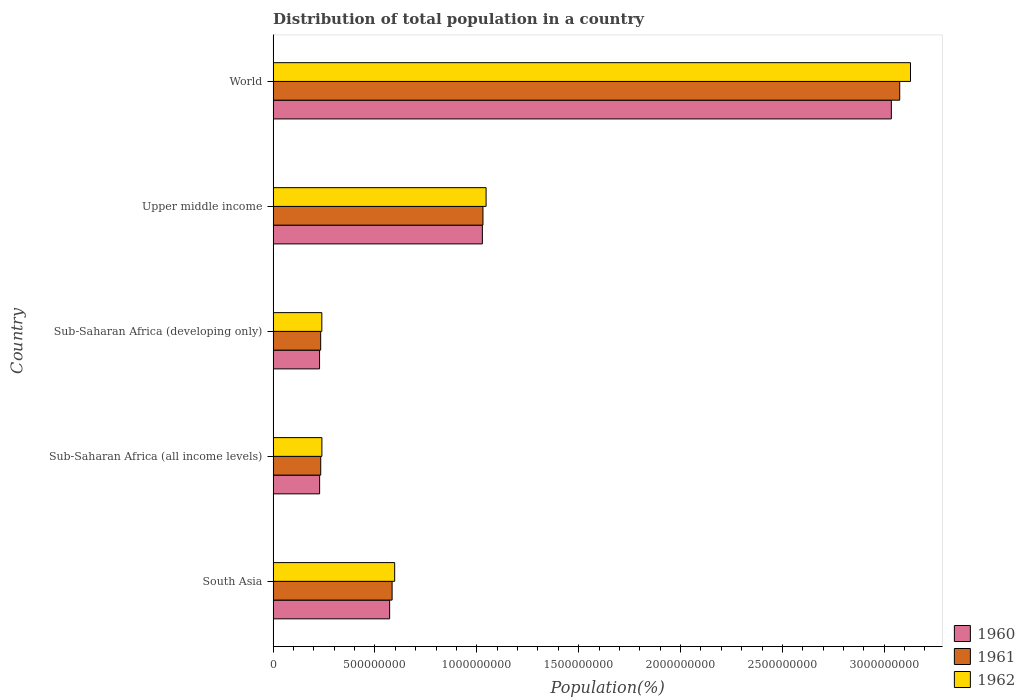Are the number of bars on each tick of the Y-axis equal?
Your answer should be very brief. Yes. How many bars are there on the 1st tick from the bottom?
Your answer should be very brief. 3. What is the label of the 2nd group of bars from the top?
Your answer should be very brief. Upper middle income. What is the population of in 1961 in South Asia?
Provide a short and direct response. 5.84e+08. Across all countries, what is the maximum population of in 1962?
Offer a terse response. 3.13e+09. Across all countries, what is the minimum population of in 1962?
Keep it short and to the point. 2.39e+08. In which country was the population of in 1961 maximum?
Offer a very short reply. World. In which country was the population of in 1960 minimum?
Provide a short and direct response. Sub-Saharan Africa (developing only). What is the total population of in 1960 in the graph?
Your answer should be compact. 5.09e+09. What is the difference between the population of in 1960 in Upper middle income and that in World?
Your answer should be very brief. -2.01e+09. What is the difference between the population of in 1961 in Sub-Saharan Africa (all income levels) and the population of in 1962 in World?
Make the answer very short. -2.90e+09. What is the average population of in 1960 per country?
Keep it short and to the point. 1.02e+09. What is the difference between the population of in 1961 and population of in 1962 in World?
Your answer should be very brief. -5.30e+07. What is the ratio of the population of in 1960 in South Asia to that in Upper middle income?
Give a very brief answer. 0.56. Is the population of in 1961 in Sub-Saharan Africa (all income levels) less than that in Upper middle income?
Ensure brevity in your answer.  Yes. Is the difference between the population of in 1961 in Sub-Saharan Africa (all income levels) and Sub-Saharan Africa (developing only) greater than the difference between the population of in 1962 in Sub-Saharan Africa (all income levels) and Sub-Saharan Africa (developing only)?
Ensure brevity in your answer.  No. What is the difference between the highest and the second highest population of in 1960?
Your answer should be compact. 2.01e+09. What is the difference between the highest and the lowest population of in 1962?
Your response must be concise. 2.89e+09. Is it the case that in every country, the sum of the population of in 1962 and population of in 1961 is greater than the population of in 1960?
Keep it short and to the point. Yes. Are all the bars in the graph horizontal?
Give a very brief answer. Yes. How many countries are there in the graph?
Provide a short and direct response. 5. What is the difference between two consecutive major ticks on the X-axis?
Offer a very short reply. 5.00e+08. How many legend labels are there?
Keep it short and to the point. 3. How are the legend labels stacked?
Keep it short and to the point. Vertical. What is the title of the graph?
Provide a short and direct response. Distribution of total population in a country. What is the label or title of the X-axis?
Your answer should be very brief. Population(%). What is the label or title of the Y-axis?
Ensure brevity in your answer.  Country. What is the Population(%) in 1960 in South Asia?
Make the answer very short. 5.72e+08. What is the Population(%) in 1961 in South Asia?
Ensure brevity in your answer.  5.84e+08. What is the Population(%) of 1962 in South Asia?
Your response must be concise. 5.97e+08. What is the Population(%) of 1960 in Sub-Saharan Africa (all income levels)?
Give a very brief answer. 2.28e+08. What is the Population(%) in 1961 in Sub-Saharan Africa (all income levels)?
Offer a terse response. 2.34e+08. What is the Population(%) in 1962 in Sub-Saharan Africa (all income levels)?
Make the answer very short. 2.39e+08. What is the Population(%) in 1960 in Sub-Saharan Africa (developing only)?
Offer a terse response. 2.28e+08. What is the Population(%) in 1961 in Sub-Saharan Africa (developing only)?
Keep it short and to the point. 2.33e+08. What is the Population(%) in 1962 in Sub-Saharan Africa (developing only)?
Make the answer very short. 2.39e+08. What is the Population(%) in 1960 in Upper middle income?
Make the answer very short. 1.03e+09. What is the Population(%) in 1961 in Upper middle income?
Your answer should be very brief. 1.03e+09. What is the Population(%) of 1962 in Upper middle income?
Your response must be concise. 1.05e+09. What is the Population(%) in 1960 in World?
Ensure brevity in your answer.  3.03e+09. What is the Population(%) in 1961 in World?
Provide a short and direct response. 3.08e+09. What is the Population(%) of 1962 in World?
Keep it short and to the point. 3.13e+09. Across all countries, what is the maximum Population(%) in 1960?
Provide a succinct answer. 3.03e+09. Across all countries, what is the maximum Population(%) of 1961?
Provide a succinct answer. 3.08e+09. Across all countries, what is the maximum Population(%) in 1962?
Offer a terse response. 3.13e+09. Across all countries, what is the minimum Population(%) in 1960?
Keep it short and to the point. 2.28e+08. Across all countries, what is the minimum Population(%) of 1961?
Keep it short and to the point. 2.33e+08. Across all countries, what is the minimum Population(%) of 1962?
Make the answer very short. 2.39e+08. What is the total Population(%) in 1960 in the graph?
Keep it short and to the point. 5.09e+09. What is the total Population(%) of 1961 in the graph?
Provide a short and direct response. 5.16e+09. What is the total Population(%) of 1962 in the graph?
Your answer should be compact. 5.25e+09. What is the difference between the Population(%) of 1960 in South Asia and that in Sub-Saharan Africa (all income levels)?
Your answer should be very brief. 3.44e+08. What is the difference between the Population(%) of 1961 in South Asia and that in Sub-Saharan Africa (all income levels)?
Ensure brevity in your answer.  3.50e+08. What is the difference between the Population(%) in 1962 in South Asia and that in Sub-Saharan Africa (all income levels)?
Offer a very short reply. 3.57e+08. What is the difference between the Population(%) of 1960 in South Asia and that in Sub-Saharan Africa (developing only)?
Keep it short and to the point. 3.44e+08. What is the difference between the Population(%) in 1961 in South Asia and that in Sub-Saharan Africa (developing only)?
Your response must be concise. 3.51e+08. What is the difference between the Population(%) in 1962 in South Asia and that in Sub-Saharan Africa (developing only)?
Provide a succinct answer. 3.58e+08. What is the difference between the Population(%) in 1960 in South Asia and that in Upper middle income?
Provide a short and direct response. -4.55e+08. What is the difference between the Population(%) in 1961 in South Asia and that in Upper middle income?
Ensure brevity in your answer.  -4.46e+08. What is the difference between the Population(%) of 1962 in South Asia and that in Upper middle income?
Offer a very short reply. -4.49e+08. What is the difference between the Population(%) of 1960 in South Asia and that in World?
Your answer should be compact. -2.46e+09. What is the difference between the Population(%) of 1961 in South Asia and that in World?
Offer a very short reply. -2.49e+09. What is the difference between the Population(%) in 1962 in South Asia and that in World?
Provide a short and direct response. -2.53e+09. What is the difference between the Population(%) of 1960 in Sub-Saharan Africa (all income levels) and that in Sub-Saharan Africa (developing only)?
Give a very brief answer. 2.94e+05. What is the difference between the Population(%) in 1961 in Sub-Saharan Africa (all income levels) and that in Sub-Saharan Africa (developing only)?
Offer a very short reply. 2.98e+05. What is the difference between the Population(%) of 1962 in Sub-Saharan Africa (all income levels) and that in Sub-Saharan Africa (developing only)?
Give a very brief answer. 3.02e+05. What is the difference between the Population(%) in 1960 in Sub-Saharan Africa (all income levels) and that in Upper middle income?
Keep it short and to the point. -7.99e+08. What is the difference between the Population(%) of 1961 in Sub-Saharan Africa (all income levels) and that in Upper middle income?
Ensure brevity in your answer.  -7.96e+08. What is the difference between the Population(%) in 1962 in Sub-Saharan Africa (all income levels) and that in Upper middle income?
Ensure brevity in your answer.  -8.06e+08. What is the difference between the Population(%) in 1960 in Sub-Saharan Africa (all income levels) and that in World?
Provide a succinct answer. -2.81e+09. What is the difference between the Population(%) of 1961 in Sub-Saharan Africa (all income levels) and that in World?
Your answer should be compact. -2.84e+09. What is the difference between the Population(%) in 1962 in Sub-Saharan Africa (all income levels) and that in World?
Give a very brief answer. -2.89e+09. What is the difference between the Population(%) in 1960 in Sub-Saharan Africa (developing only) and that in Upper middle income?
Keep it short and to the point. -7.99e+08. What is the difference between the Population(%) in 1961 in Sub-Saharan Africa (developing only) and that in Upper middle income?
Offer a very short reply. -7.97e+08. What is the difference between the Population(%) of 1962 in Sub-Saharan Africa (developing only) and that in Upper middle income?
Make the answer very short. -8.06e+08. What is the difference between the Population(%) in 1960 in Sub-Saharan Africa (developing only) and that in World?
Provide a short and direct response. -2.81e+09. What is the difference between the Population(%) of 1961 in Sub-Saharan Africa (developing only) and that in World?
Provide a short and direct response. -2.84e+09. What is the difference between the Population(%) in 1962 in Sub-Saharan Africa (developing only) and that in World?
Provide a succinct answer. -2.89e+09. What is the difference between the Population(%) of 1960 in Upper middle income and that in World?
Provide a succinct answer. -2.01e+09. What is the difference between the Population(%) of 1961 in Upper middle income and that in World?
Your response must be concise. -2.05e+09. What is the difference between the Population(%) of 1962 in Upper middle income and that in World?
Keep it short and to the point. -2.08e+09. What is the difference between the Population(%) of 1960 in South Asia and the Population(%) of 1961 in Sub-Saharan Africa (all income levels)?
Give a very brief answer. 3.38e+08. What is the difference between the Population(%) in 1960 in South Asia and the Population(%) in 1962 in Sub-Saharan Africa (all income levels)?
Make the answer very short. 3.33e+08. What is the difference between the Population(%) of 1961 in South Asia and the Population(%) of 1962 in Sub-Saharan Africa (all income levels)?
Provide a succinct answer. 3.45e+08. What is the difference between the Population(%) of 1960 in South Asia and the Population(%) of 1961 in Sub-Saharan Africa (developing only)?
Give a very brief answer. 3.39e+08. What is the difference between the Population(%) of 1960 in South Asia and the Population(%) of 1962 in Sub-Saharan Africa (developing only)?
Make the answer very short. 3.33e+08. What is the difference between the Population(%) in 1961 in South Asia and the Population(%) in 1962 in Sub-Saharan Africa (developing only)?
Give a very brief answer. 3.45e+08. What is the difference between the Population(%) of 1960 in South Asia and the Population(%) of 1961 in Upper middle income?
Give a very brief answer. -4.58e+08. What is the difference between the Population(%) in 1960 in South Asia and the Population(%) in 1962 in Upper middle income?
Your response must be concise. -4.73e+08. What is the difference between the Population(%) of 1961 in South Asia and the Population(%) of 1962 in Upper middle income?
Your response must be concise. -4.61e+08. What is the difference between the Population(%) in 1960 in South Asia and the Population(%) in 1961 in World?
Ensure brevity in your answer.  -2.50e+09. What is the difference between the Population(%) of 1960 in South Asia and the Population(%) of 1962 in World?
Keep it short and to the point. -2.56e+09. What is the difference between the Population(%) of 1961 in South Asia and the Population(%) of 1962 in World?
Provide a succinct answer. -2.54e+09. What is the difference between the Population(%) in 1960 in Sub-Saharan Africa (all income levels) and the Population(%) in 1961 in Sub-Saharan Africa (developing only)?
Offer a terse response. -5.19e+06. What is the difference between the Population(%) in 1960 in Sub-Saharan Africa (all income levels) and the Population(%) in 1962 in Sub-Saharan Africa (developing only)?
Ensure brevity in your answer.  -1.08e+07. What is the difference between the Population(%) in 1961 in Sub-Saharan Africa (all income levels) and the Population(%) in 1962 in Sub-Saharan Africa (developing only)?
Ensure brevity in your answer.  -5.34e+06. What is the difference between the Population(%) in 1960 in Sub-Saharan Africa (all income levels) and the Population(%) in 1961 in Upper middle income?
Your response must be concise. -8.02e+08. What is the difference between the Population(%) of 1960 in Sub-Saharan Africa (all income levels) and the Population(%) of 1962 in Upper middle income?
Give a very brief answer. -8.17e+08. What is the difference between the Population(%) of 1961 in Sub-Saharan Africa (all income levels) and the Population(%) of 1962 in Upper middle income?
Your response must be concise. -8.12e+08. What is the difference between the Population(%) of 1960 in Sub-Saharan Africa (all income levels) and the Population(%) of 1961 in World?
Make the answer very short. -2.85e+09. What is the difference between the Population(%) in 1960 in Sub-Saharan Africa (all income levels) and the Population(%) in 1962 in World?
Give a very brief answer. -2.90e+09. What is the difference between the Population(%) of 1961 in Sub-Saharan Africa (all income levels) and the Population(%) of 1962 in World?
Ensure brevity in your answer.  -2.90e+09. What is the difference between the Population(%) in 1960 in Sub-Saharan Africa (developing only) and the Population(%) in 1961 in Upper middle income?
Your answer should be very brief. -8.02e+08. What is the difference between the Population(%) in 1960 in Sub-Saharan Africa (developing only) and the Population(%) in 1962 in Upper middle income?
Ensure brevity in your answer.  -8.18e+08. What is the difference between the Population(%) of 1961 in Sub-Saharan Africa (developing only) and the Population(%) of 1962 in Upper middle income?
Provide a succinct answer. -8.12e+08. What is the difference between the Population(%) in 1960 in Sub-Saharan Africa (developing only) and the Population(%) in 1961 in World?
Give a very brief answer. -2.85e+09. What is the difference between the Population(%) in 1960 in Sub-Saharan Africa (developing only) and the Population(%) in 1962 in World?
Provide a short and direct response. -2.90e+09. What is the difference between the Population(%) in 1961 in Sub-Saharan Africa (developing only) and the Population(%) in 1962 in World?
Provide a short and direct response. -2.90e+09. What is the difference between the Population(%) in 1960 in Upper middle income and the Population(%) in 1961 in World?
Your answer should be very brief. -2.05e+09. What is the difference between the Population(%) of 1960 in Upper middle income and the Population(%) of 1962 in World?
Your answer should be compact. -2.10e+09. What is the difference between the Population(%) in 1961 in Upper middle income and the Population(%) in 1962 in World?
Offer a terse response. -2.10e+09. What is the average Population(%) of 1960 per country?
Provide a succinct answer. 1.02e+09. What is the average Population(%) in 1961 per country?
Make the answer very short. 1.03e+09. What is the average Population(%) of 1962 per country?
Offer a terse response. 1.05e+09. What is the difference between the Population(%) of 1960 and Population(%) of 1961 in South Asia?
Offer a very short reply. -1.21e+07. What is the difference between the Population(%) of 1960 and Population(%) of 1962 in South Asia?
Ensure brevity in your answer.  -2.47e+07. What is the difference between the Population(%) in 1961 and Population(%) in 1962 in South Asia?
Ensure brevity in your answer.  -1.26e+07. What is the difference between the Population(%) of 1960 and Population(%) of 1961 in Sub-Saharan Africa (all income levels)?
Your answer should be very brief. -5.49e+06. What is the difference between the Population(%) of 1960 and Population(%) of 1962 in Sub-Saharan Africa (all income levels)?
Make the answer very short. -1.11e+07. What is the difference between the Population(%) of 1961 and Population(%) of 1962 in Sub-Saharan Africa (all income levels)?
Provide a short and direct response. -5.64e+06. What is the difference between the Population(%) in 1960 and Population(%) in 1961 in Sub-Saharan Africa (developing only)?
Keep it short and to the point. -5.49e+06. What is the difference between the Population(%) of 1960 and Population(%) of 1962 in Sub-Saharan Africa (developing only)?
Your response must be concise. -1.11e+07. What is the difference between the Population(%) in 1961 and Population(%) in 1962 in Sub-Saharan Africa (developing only)?
Make the answer very short. -5.64e+06. What is the difference between the Population(%) in 1960 and Population(%) in 1961 in Upper middle income?
Provide a short and direct response. -2.91e+06. What is the difference between the Population(%) in 1960 and Population(%) in 1962 in Upper middle income?
Keep it short and to the point. -1.82e+07. What is the difference between the Population(%) in 1961 and Population(%) in 1962 in Upper middle income?
Make the answer very short. -1.53e+07. What is the difference between the Population(%) in 1960 and Population(%) in 1961 in World?
Ensure brevity in your answer.  -4.11e+07. What is the difference between the Population(%) of 1960 and Population(%) of 1962 in World?
Your response must be concise. -9.40e+07. What is the difference between the Population(%) in 1961 and Population(%) in 1962 in World?
Provide a short and direct response. -5.30e+07. What is the ratio of the Population(%) in 1960 in South Asia to that in Sub-Saharan Africa (all income levels)?
Give a very brief answer. 2.51. What is the ratio of the Population(%) of 1961 in South Asia to that in Sub-Saharan Africa (all income levels)?
Your answer should be very brief. 2.5. What is the ratio of the Population(%) in 1962 in South Asia to that in Sub-Saharan Africa (all income levels)?
Your response must be concise. 2.49. What is the ratio of the Population(%) of 1960 in South Asia to that in Sub-Saharan Africa (developing only)?
Give a very brief answer. 2.51. What is the ratio of the Population(%) in 1961 in South Asia to that in Sub-Saharan Africa (developing only)?
Provide a succinct answer. 2.5. What is the ratio of the Population(%) of 1962 in South Asia to that in Sub-Saharan Africa (developing only)?
Make the answer very short. 2.5. What is the ratio of the Population(%) of 1960 in South Asia to that in Upper middle income?
Offer a terse response. 0.56. What is the ratio of the Population(%) in 1961 in South Asia to that in Upper middle income?
Your answer should be very brief. 0.57. What is the ratio of the Population(%) in 1962 in South Asia to that in Upper middle income?
Your answer should be very brief. 0.57. What is the ratio of the Population(%) of 1960 in South Asia to that in World?
Give a very brief answer. 0.19. What is the ratio of the Population(%) of 1961 in South Asia to that in World?
Offer a very short reply. 0.19. What is the ratio of the Population(%) of 1962 in South Asia to that in World?
Offer a terse response. 0.19. What is the ratio of the Population(%) of 1961 in Sub-Saharan Africa (all income levels) to that in Sub-Saharan Africa (developing only)?
Provide a short and direct response. 1. What is the ratio of the Population(%) in 1962 in Sub-Saharan Africa (all income levels) to that in Sub-Saharan Africa (developing only)?
Provide a succinct answer. 1. What is the ratio of the Population(%) of 1960 in Sub-Saharan Africa (all income levels) to that in Upper middle income?
Offer a terse response. 0.22. What is the ratio of the Population(%) of 1961 in Sub-Saharan Africa (all income levels) to that in Upper middle income?
Offer a terse response. 0.23. What is the ratio of the Population(%) in 1962 in Sub-Saharan Africa (all income levels) to that in Upper middle income?
Your response must be concise. 0.23. What is the ratio of the Population(%) of 1960 in Sub-Saharan Africa (all income levels) to that in World?
Make the answer very short. 0.08. What is the ratio of the Population(%) in 1961 in Sub-Saharan Africa (all income levels) to that in World?
Make the answer very short. 0.08. What is the ratio of the Population(%) of 1962 in Sub-Saharan Africa (all income levels) to that in World?
Offer a terse response. 0.08. What is the ratio of the Population(%) in 1960 in Sub-Saharan Africa (developing only) to that in Upper middle income?
Make the answer very short. 0.22. What is the ratio of the Population(%) in 1961 in Sub-Saharan Africa (developing only) to that in Upper middle income?
Your response must be concise. 0.23. What is the ratio of the Population(%) of 1962 in Sub-Saharan Africa (developing only) to that in Upper middle income?
Provide a succinct answer. 0.23. What is the ratio of the Population(%) of 1960 in Sub-Saharan Africa (developing only) to that in World?
Offer a very short reply. 0.08. What is the ratio of the Population(%) in 1961 in Sub-Saharan Africa (developing only) to that in World?
Ensure brevity in your answer.  0.08. What is the ratio of the Population(%) of 1962 in Sub-Saharan Africa (developing only) to that in World?
Ensure brevity in your answer.  0.08. What is the ratio of the Population(%) of 1960 in Upper middle income to that in World?
Your answer should be very brief. 0.34. What is the ratio of the Population(%) in 1961 in Upper middle income to that in World?
Give a very brief answer. 0.33. What is the ratio of the Population(%) in 1962 in Upper middle income to that in World?
Offer a very short reply. 0.33. What is the difference between the highest and the second highest Population(%) of 1960?
Your answer should be very brief. 2.01e+09. What is the difference between the highest and the second highest Population(%) of 1961?
Give a very brief answer. 2.05e+09. What is the difference between the highest and the second highest Population(%) in 1962?
Provide a succinct answer. 2.08e+09. What is the difference between the highest and the lowest Population(%) in 1960?
Provide a succinct answer. 2.81e+09. What is the difference between the highest and the lowest Population(%) of 1961?
Keep it short and to the point. 2.84e+09. What is the difference between the highest and the lowest Population(%) in 1962?
Offer a very short reply. 2.89e+09. 